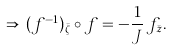Convert formula to latex. <formula><loc_0><loc_0><loc_500><loc_500>\Rightarrow \, ( f ^ { - 1 } ) _ { \bar { \zeta } } \circ f = - \frac { 1 } { J } \, f _ { \bar { z } } .</formula> 